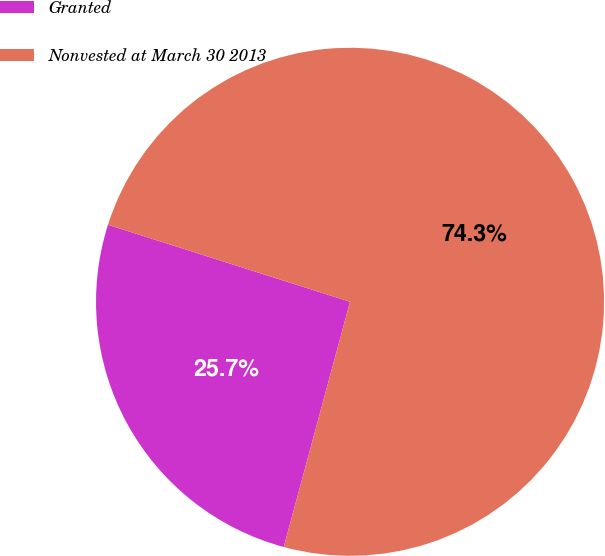<chart> <loc_0><loc_0><loc_500><loc_500><pie_chart><fcel>Granted<fcel>Nonvested at March 30 2013<nl><fcel>25.7%<fcel>74.3%<nl></chart> 